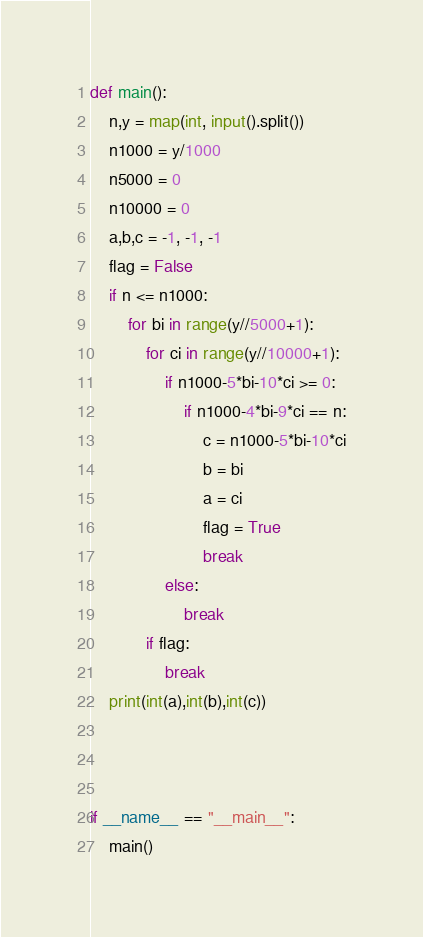<code> <loc_0><loc_0><loc_500><loc_500><_Python_>def main():
    n,y = map(int, input().split())
    n1000 = y/1000
    n5000 = 0
    n10000 = 0
    a,b,c = -1, -1, -1
    flag = False
    if n <= n1000:
        for bi in range(y//5000+1):
            for ci in range(y//10000+1):
                if n1000-5*bi-10*ci >= 0:
                    if n1000-4*bi-9*ci == n:
                        c = n1000-5*bi-10*ci
                        b = bi
                        a = ci
                        flag = True
                        break
                else:
                    break
            if flag:
                break
    print(int(a),int(b),int(c))
        


if __name__ == "__main__":
    main()</code> 